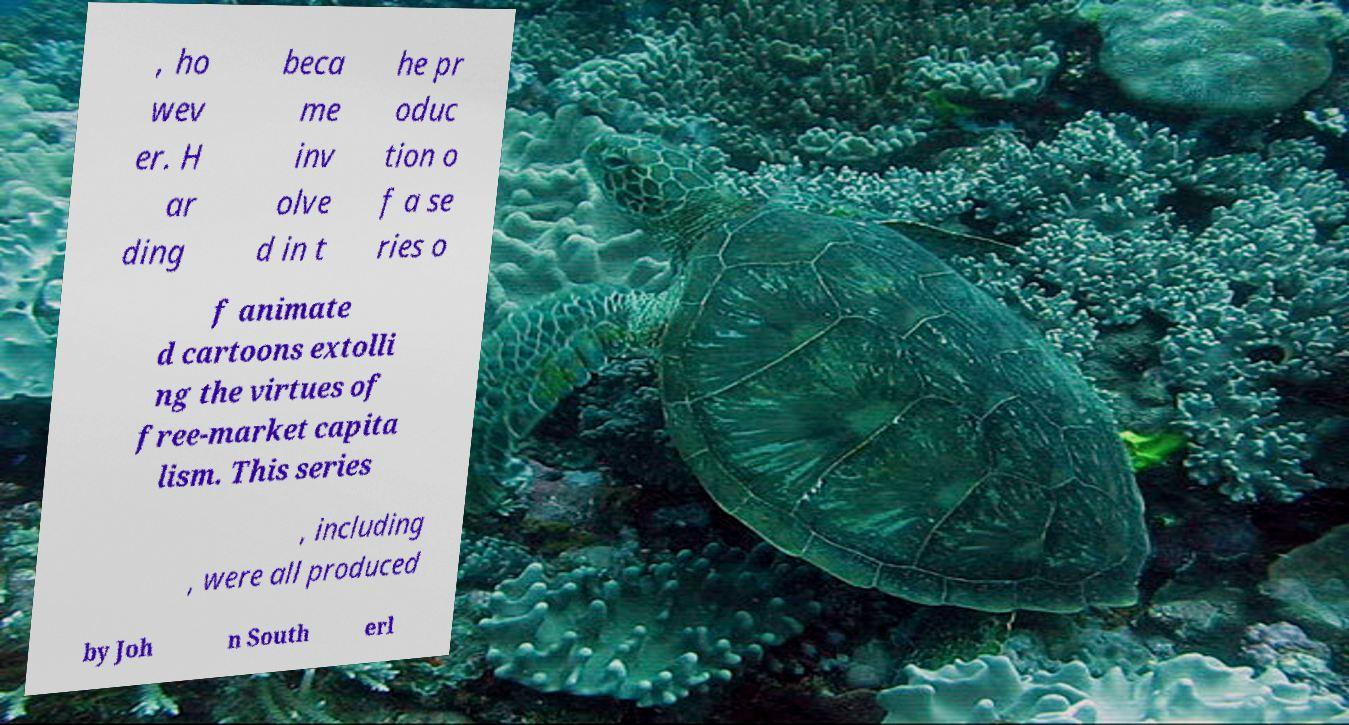There's text embedded in this image that I need extracted. Can you transcribe it verbatim? , ho wev er. H ar ding beca me inv olve d in t he pr oduc tion o f a se ries o f animate d cartoons extolli ng the virtues of free-market capita lism. This series , including , were all produced by Joh n South erl 